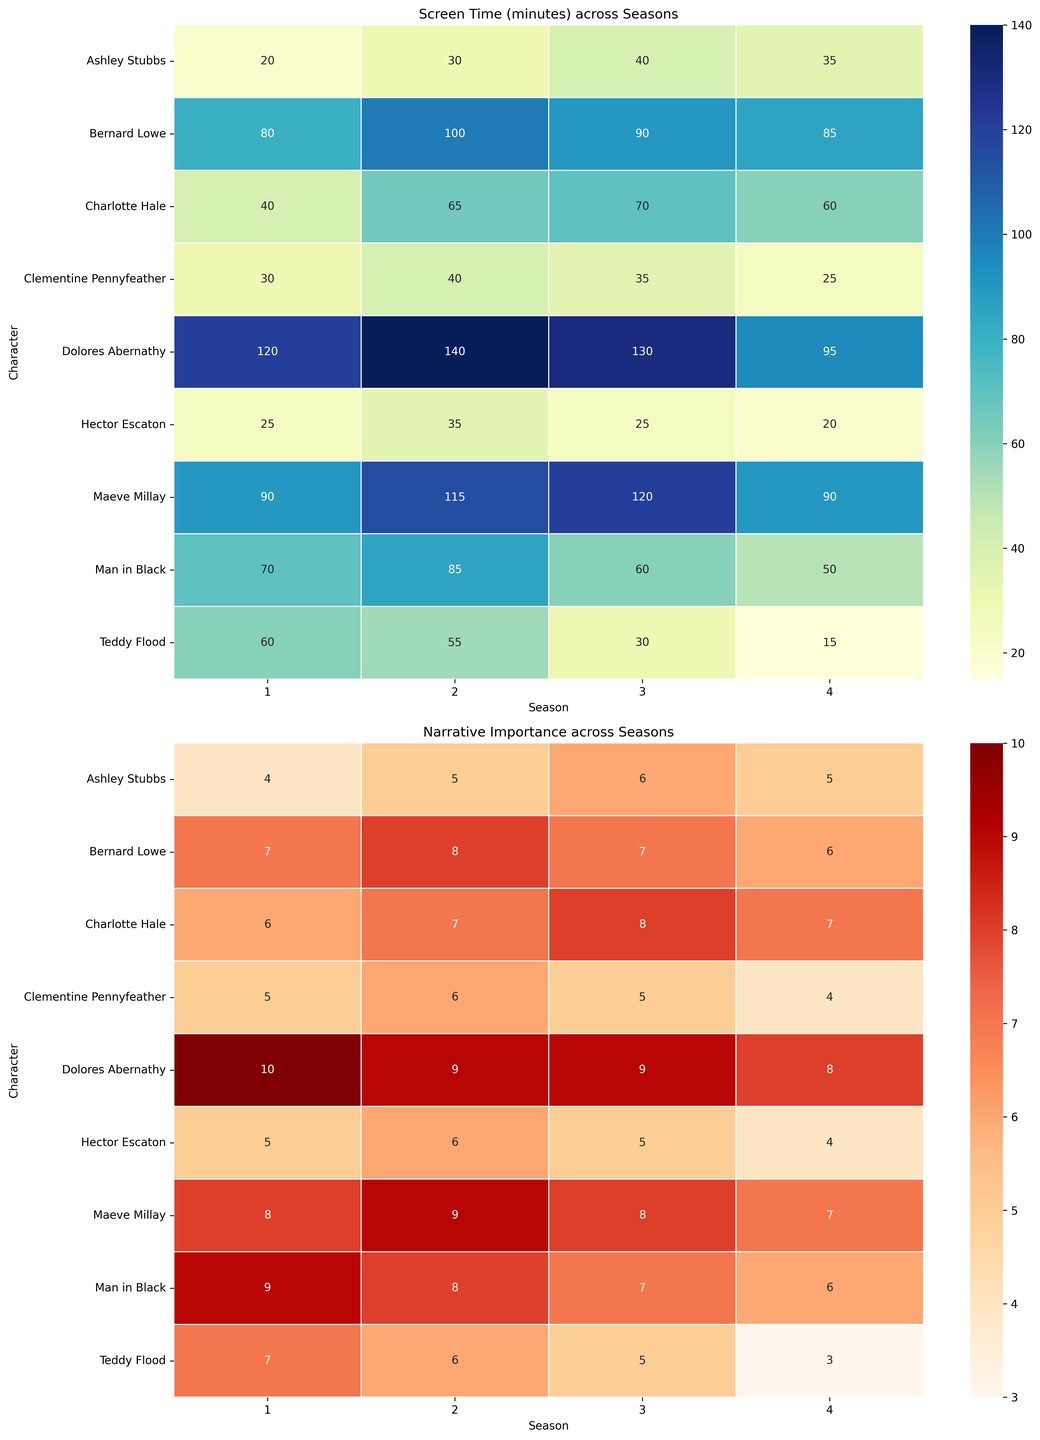Which character has the highest screen time in Season 2? In the Screen Time heatmap, locate the column for Season 2 and look for the highest number. Identify the character associated with that number.
Answer: Dolores Abernathy Which character's narrative importance decreased the most from Season 3 to Season 4? In the Narrative Importance heatmap, compare the values for Season 3 and Season 4 for each character. Determine which character has the largest decrease.
Answer: Teddy Flood What is the combined screen time of Bernard Lowe across all seasons? In the Screen Time heatmap, find the screen time values for Bernard Lowe across all seasons, then sum them up: 80 + 100 + 90 + 85 = 355.
Answer: 355 minutes Who maintained the highest narrative importance over all seasons? In the Narrative Importance heatmap, observe the values for each character across all seasons and identify the one with consistently high values.
Answer: Dolores Abernathy Between Maeve Millay and Dolores Abernathy, who had more screen time in Season 3? In the Screen Time heatmap, compare the screen time values for Maeve Millay and Dolores Abernathy in Season 3.
Answer: Maeve Millay Which character had the lowest narrative importance in Season 4? In the Narrative Importance heatmap, find the minimum value in the column for Season 4 and identify the corresponding character.
Answer: Teddy Flood Did any character's narrative importance remain the same from Season 1 to Season 4? If so, who? In the Narrative Importance heatmap, check each character's values for Season 1 and Season 4 to see if any are the same.
Answer: No Which character saw an increase in screen time from Season 1 to Season 2? In the Screen Time heatmap, compare the values for Season 1 and Season 2 for every character. Identify those with an increased screen time.
Answer: Bernard Lowe, Charlotte Hale, Clementine Pennyfeather, Ashley Stubbs, Hector Escaton 